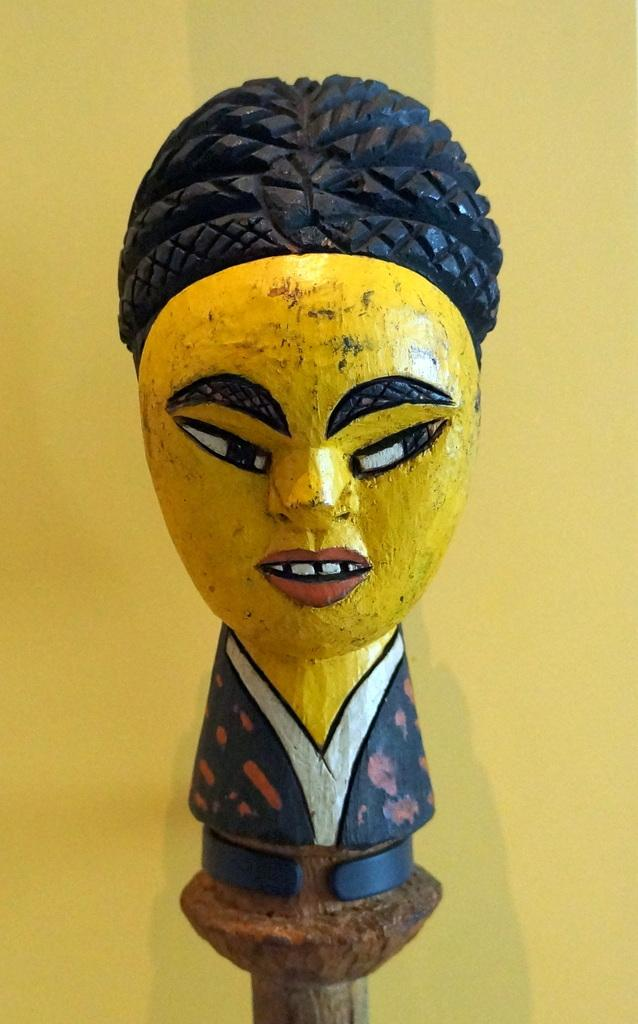What object can be seen in the image? There is a toy in the image. What color is the background of the image? The background of the image is yellow. Can you see a spade digging into the ground in the image? There is no spade or ground visible in the image; it features a toy against a yellow background. What type of prose is being recited by the toy in the image? The toy is not reciting any prose in the image, as it is an inanimate object. 